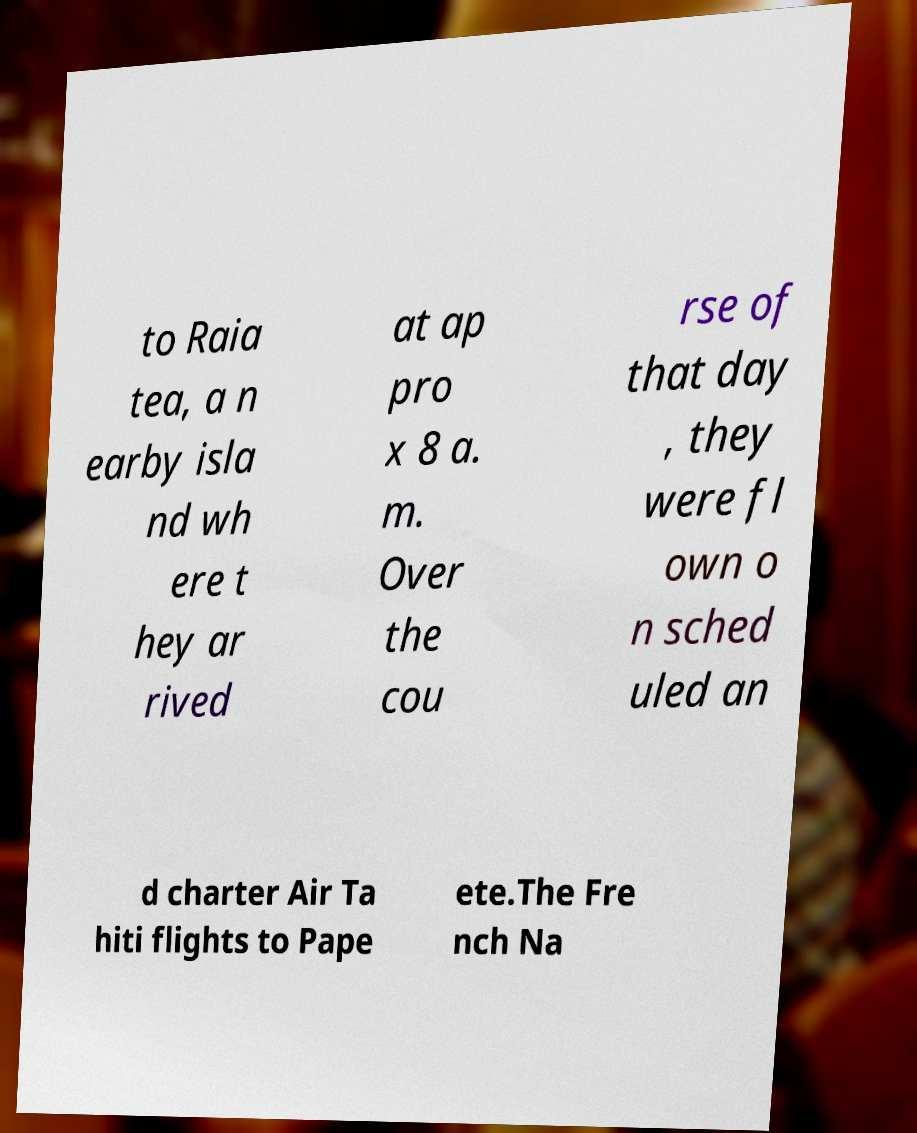Could you extract and type out the text from this image? to Raia tea, a n earby isla nd wh ere t hey ar rived at ap pro x 8 a. m. Over the cou rse of that day , they were fl own o n sched uled an d charter Air Ta hiti flights to Pape ete.The Fre nch Na 